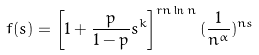<formula> <loc_0><loc_0><loc_500><loc_500>f ( s ) = \left [ 1 + \frac { p } { 1 - p } s ^ { k } \right ] ^ { r n \ln n } ( \frac { 1 } { n ^ { \alpha } } ) ^ { n s }</formula> 